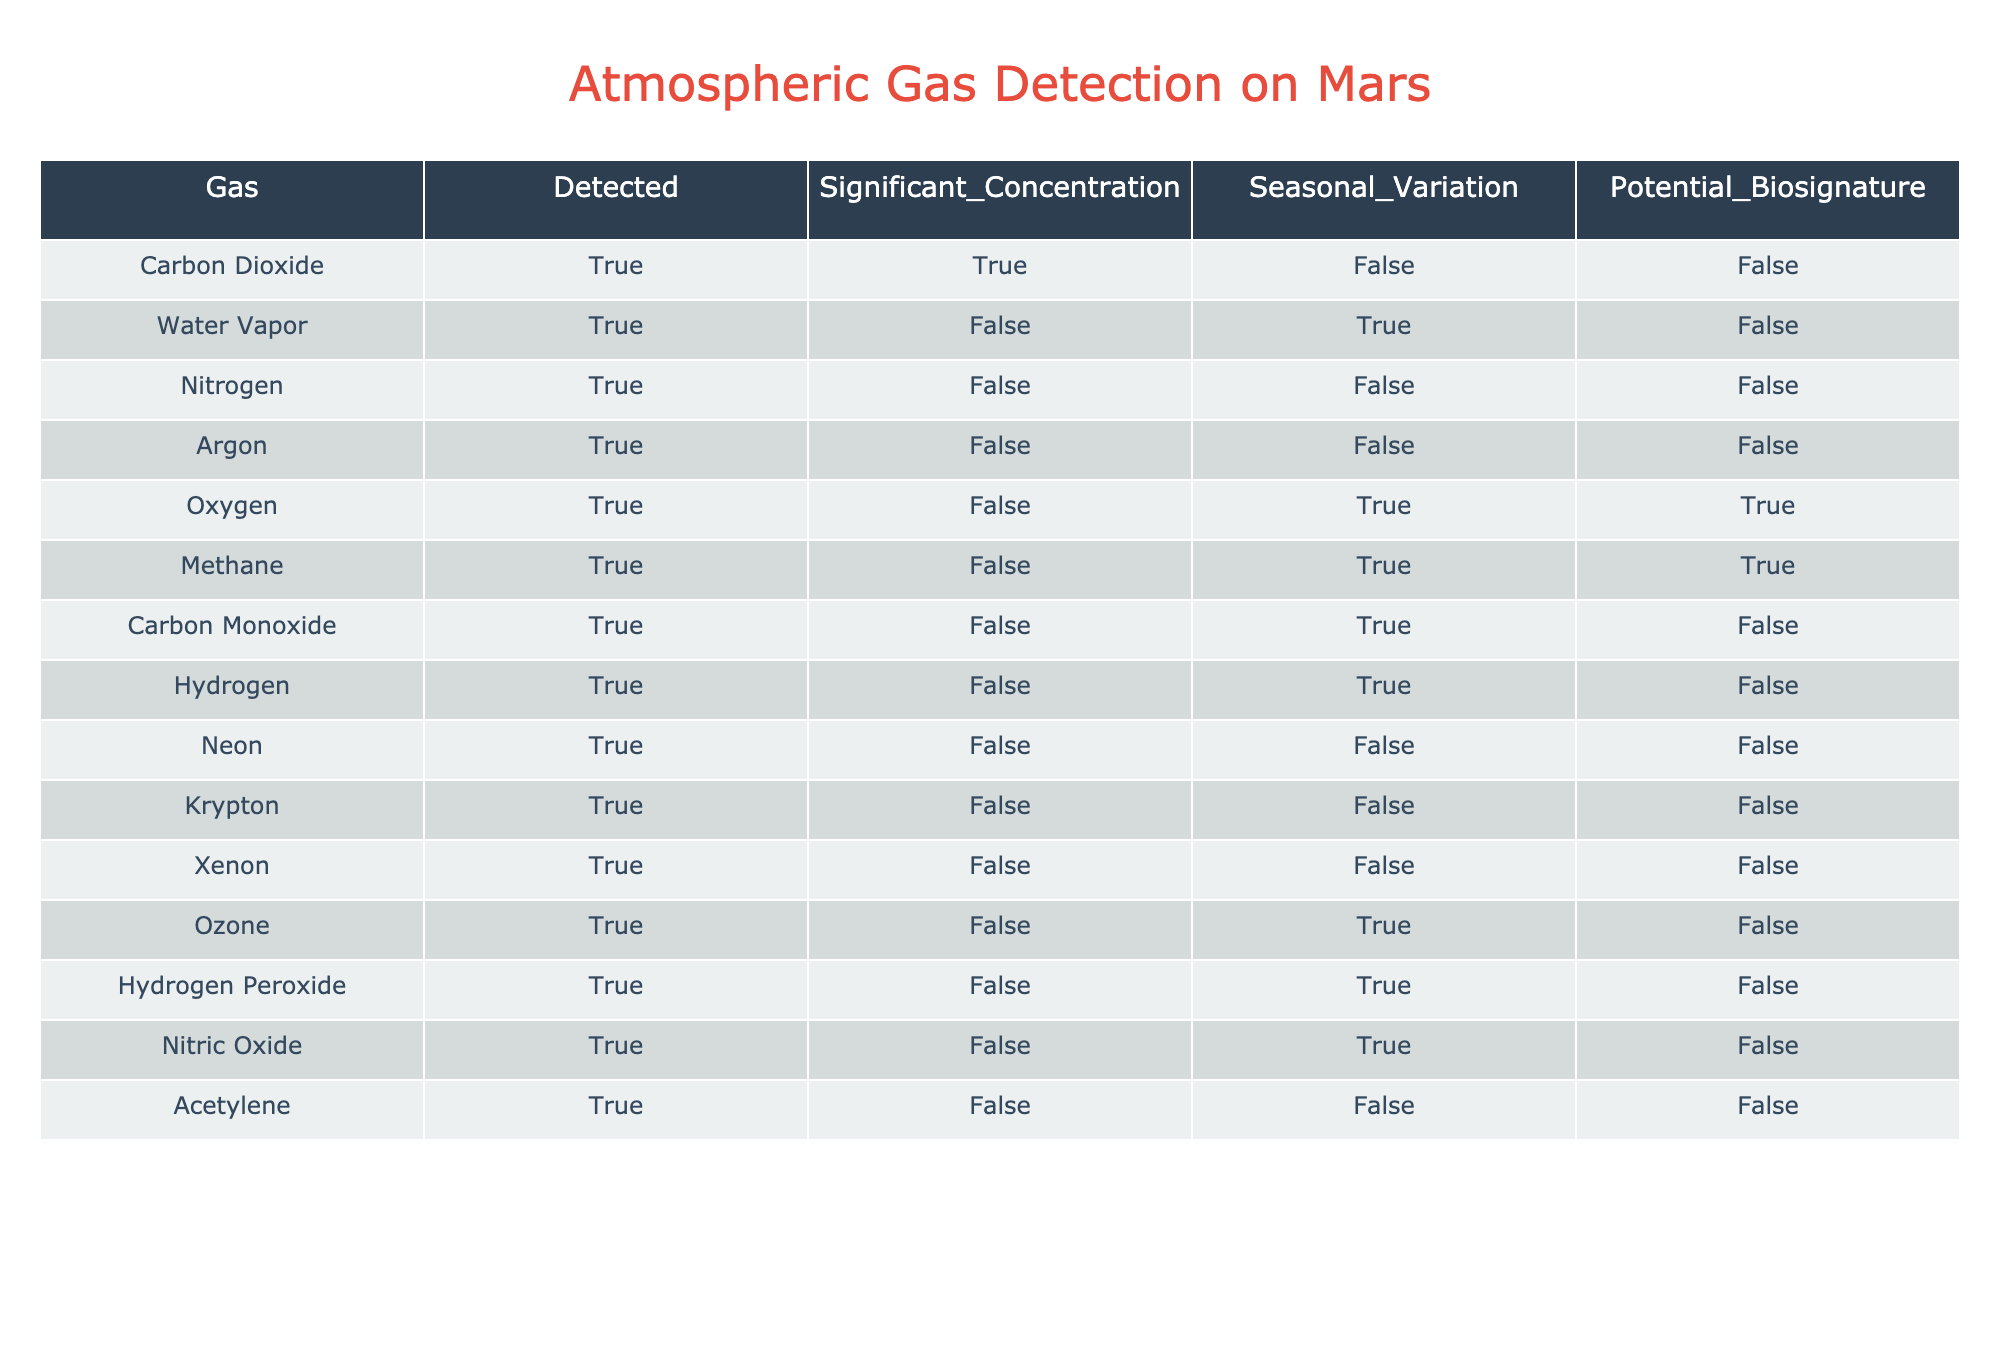What gases were detected on Mars? The column titled "Gas" lists all the gases that have been detected on Mars. By reviewing this column, I can see that the detected gases include Carbon Dioxide, Water Vapor, Nitrogen, Argon, Oxygen, Methane, Carbon Monoxide, Hydrogen, Neon, Krypton, Xenon, Ozone, Hydrogen Peroxide, Nitric Oxide, and Acetylene.
Answer: Carbon Dioxide, Water Vapor, Nitrogen, Argon, Oxygen, Methane, Carbon Monoxide, Hydrogen, Neon, Krypton, Xenon, Ozone, Hydrogen Peroxide, Nitric Oxide, Acetylene Which gas is the only significant biosignature indicated in the table? I review the column titled "Potential_Biosignature" for all gases detected on Mars. I find that the only gas that is indicated as a potential biosignature is Oxygen, as it is the only one with "True" in this column.
Answer: Oxygen How many gases exhibit significant concentrations? I look at the column titled "Significant_Concentration" for each gas. The only gas that has "True" in the significant concentration column is Carbon Dioxide. Therefore, I find that there is only one gas with a significant concentration.
Answer: 1 Is Water Vapor detected in Mars' atmosphere without significant concentration? I check the rows corresponding to Water Vapor. It states "True" under "Detected" and "False" under "Significant_Concentration," which confirms that Water Vapor is detected but does not have a significant concentration.
Answer: Yes Which gases exhibit seasonal variation? I assess the "Seasonal_Variation" column for all detected gases. The gases that show seasonal variation are Water Vapor, Oxygen, Methane, Carbon Monoxide, Hydrogen, Ozone, and Hydrogen Peroxide, as they all indicate "True." I count these gases to identify how many there are.
Answer: 7 What is the relationship between the presence of a biosignature and significant concentration in the gases detected? I analyze the columns "Potential_Biosignature" and "Significant_Concentration." I see that Oxygen and Methane are potential biosignatures but do not have significant concentrations. Yet, Carbon Dioxide does show significant concentration but is not a potential biosignature. Therefore, it seems that there is no direct relationship, as some gases can be biosignatures without significant concentrations.
Answer: No direct relationship How many gases detected are solely present without any seasonal variation? I browse through the "Seasonal_Variation" column and filter out all gases marked "False." The gases are Argon, Neon, Krypton, and Xenon, and I count them. Thus, there are four gases detected solely without seasonal variation.
Answer: 4 Which gas is detected in the atmosphere of Mars but is not a potential biosignature? I investigate the "Potential_Biosignature" column for gases marked "True" and "False." I see that Carbon Dioxide, Water Vapor, Nitrogen, Argon, Carbon Monoxide, Hydrogen, Neon, Krypton, Xenon, Ozone, and Hydrogen Peroxide are detected but marked as "False" denoting that these gases are not considered biosignatures.
Answer: Carbon Dioxide, Water Vapor, Nitrogen, Argon, Carbon Monoxide, Hydrogen, Neon, Krypton, Xenon, Ozone, Hydrogen Peroxide 